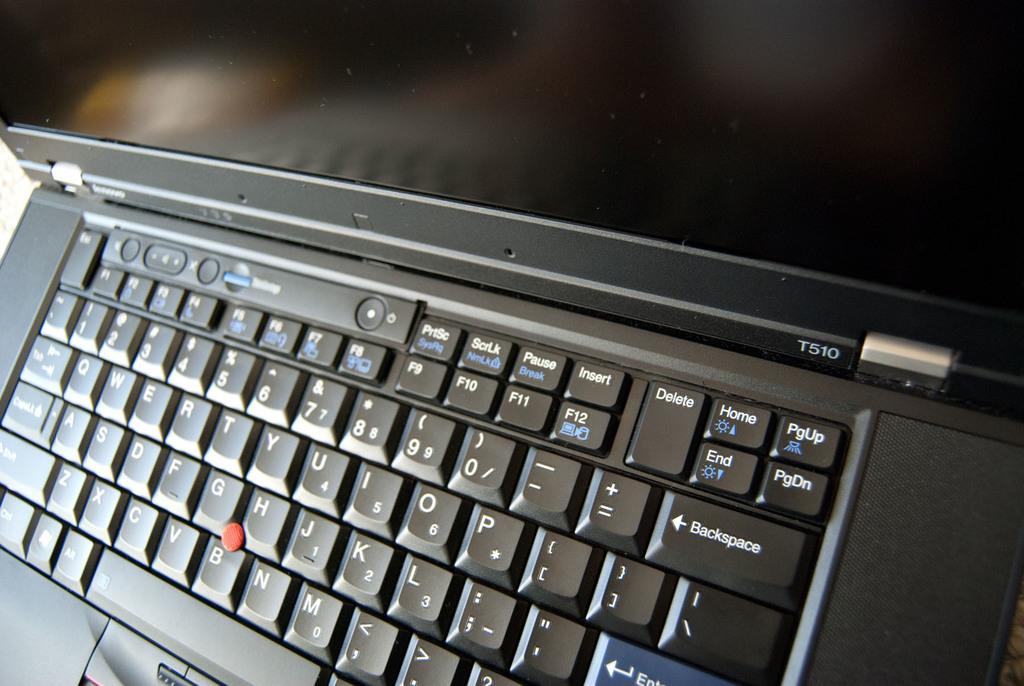What is one of the keys on the keyboard?
Provide a succinct answer. P. What is between the g, h, and b keys?
Make the answer very short. Red dot. 